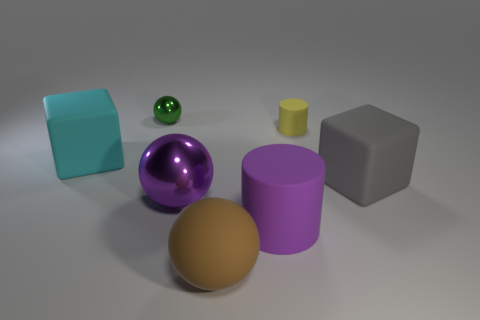Subtract all brown matte spheres. How many spheres are left? 2 Add 3 rubber cylinders. How many objects exist? 10 Subtract all brown balls. How many balls are left? 2 Subtract all blocks. How many objects are left? 5 Subtract 2 cylinders. How many cylinders are left? 0 Subtract all yellow cubes. Subtract all cyan cylinders. How many cubes are left? 2 Subtract all shiny things. Subtract all small yellow cylinders. How many objects are left? 4 Add 7 green metal balls. How many green metal balls are left? 8 Add 7 large cyan rubber objects. How many large cyan rubber objects exist? 8 Subtract 0 red cylinders. How many objects are left? 7 